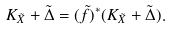Convert formula to latex. <formula><loc_0><loc_0><loc_500><loc_500>K _ { \tilde { X } } + \tilde { \Delta } = ( \tilde { f } ) ^ { * } ( K _ { \tilde { X } } + \tilde { \Delta } ) .</formula> 